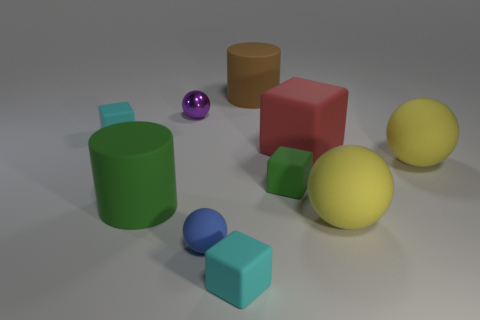Subtract 1 balls. How many balls are left? 3 Subtract all balls. How many objects are left? 6 Add 3 blue balls. How many blue balls are left? 4 Add 1 big brown cubes. How many big brown cubes exist? 1 Subtract 1 green blocks. How many objects are left? 9 Subtract all cylinders. Subtract all green cubes. How many objects are left? 7 